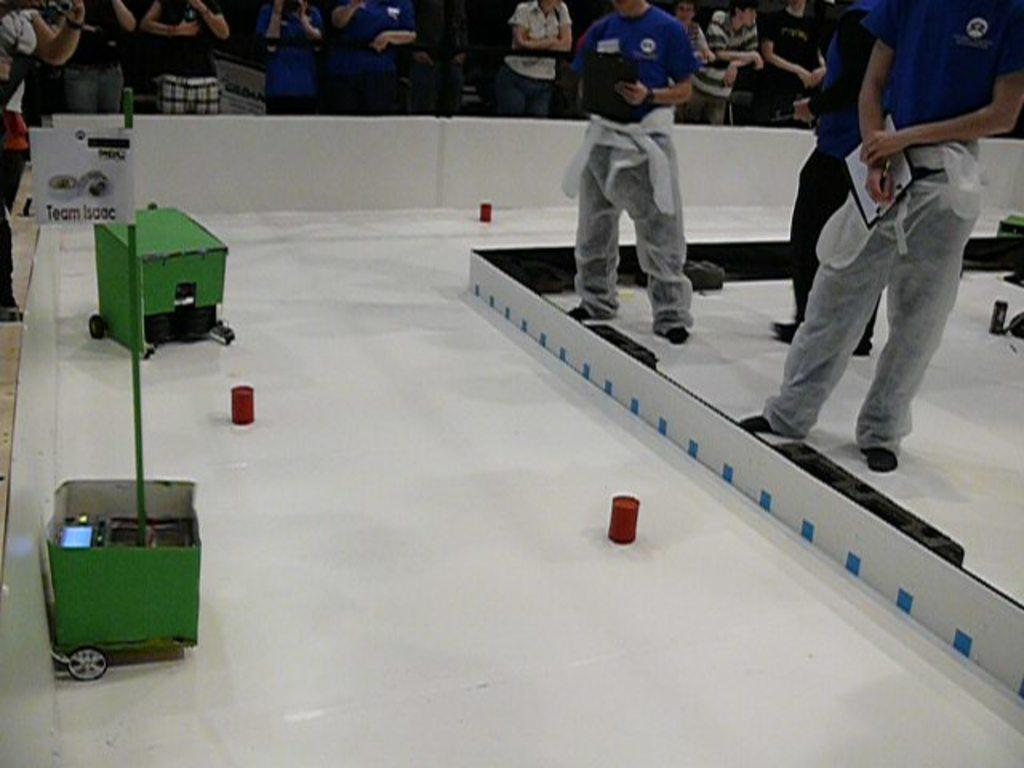What is happening in the image involving the people? There are people standing in the image, which suggests they might be participating in an event or activity. What can be seen on the ground in the image? There are objects kept on the ground in the image, but their specific nature is not mentioned in the facts. Who else is present in the image besides the people standing? There are spectators standing and watching the people in the image. What type of stew is being served to the people in the image? There is no mention of stew or any food being served in the image. 